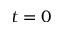Convert formula to latex. <formula><loc_0><loc_0><loc_500><loc_500>t = 0</formula> 